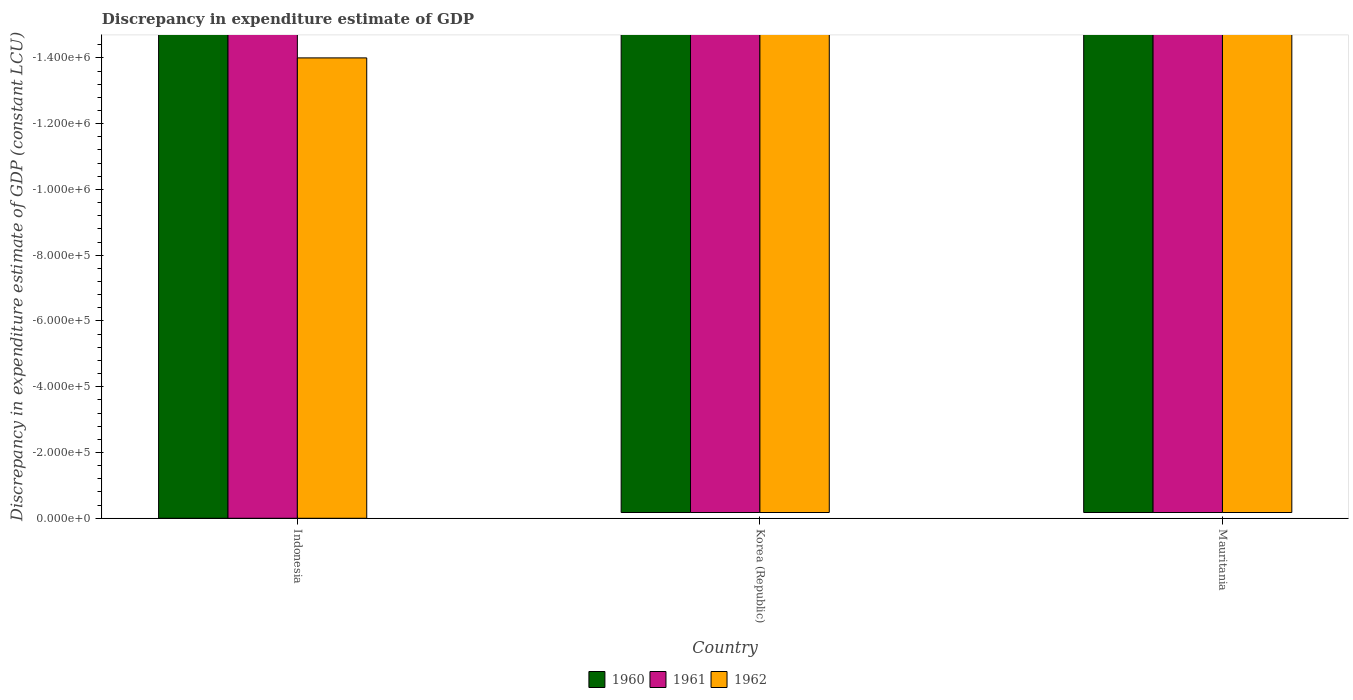Are the number of bars per tick equal to the number of legend labels?
Make the answer very short. No. Are the number of bars on each tick of the X-axis equal?
Provide a short and direct response. Yes. How many bars are there on the 2nd tick from the right?
Your answer should be compact. 0. What is the label of the 2nd group of bars from the left?
Your answer should be compact. Korea (Republic). What is the discrepancy in expenditure estimate of GDP in 1961 in Korea (Republic)?
Offer a terse response. 0. What is the total discrepancy in expenditure estimate of GDP in 1960 in the graph?
Your answer should be very brief. 0. What is the difference between the discrepancy in expenditure estimate of GDP in 1960 in Korea (Republic) and the discrepancy in expenditure estimate of GDP in 1961 in Mauritania?
Your answer should be very brief. 0. In how many countries, is the discrepancy in expenditure estimate of GDP in 1961 greater than -560000 LCU?
Offer a very short reply. 0. In how many countries, is the discrepancy in expenditure estimate of GDP in 1961 greater than the average discrepancy in expenditure estimate of GDP in 1961 taken over all countries?
Make the answer very short. 0. How many bars are there?
Your answer should be very brief. 0. How many countries are there in the graph?
Ensure brevity in your answer.  3. Are the values on the major ticks of Y-axis written in scientific E-notation?
Keep it short and to the point. Yes. Does the graph contain any zero values?
Offer a very short reply. Yes. Does the graph contain grids?
Ensure brevity in your answer.  No. Where does the legend appear in the graph?
Offer a very short reply. Bottom center. How many legend labels are there?
Your answer should be very brief. 3. How are the legend labels stacked?
Provide a succinct answer. Horizontal. What is the title of the graph?
Your response must be concise. Discrepancy in expenditure estimate of GDP. Does "2004" appear as one of the legend labels in the graph?
Make the answer very short. No. What is the label or title of the X-axis?
Ensure brevity in your answer.  Country. What is the label or title of the Y-axis?
Provide a succinct answer. Discrepancy in expenditure estimate of GDP (constant LCU). What is the Discrepancy in expenditure estimate of GDP (constant LCU) of 1961 in Mauritania?
Make the answer very short. 0. What is the total Discrepancy in expenditure estimate of GDP (constant LCU) in 1960 in the graph?
Your response must be concise. 0. What is the total Discrepancy in expenditure estimate of GDP (constant LCU) of 1961 in the graph?
Your response must be concise. 0. What is the total Discrepancy in expenditure estimate of GDP (constant LCU) of 1962 in the graph?
Keep it short and to the point. 0. What is the average Discrepancy in expenditure estimate of GDP (constant LCU) in 1960 per country?
Give a very brief answer. 0. What is the average Discrepancy in expenditure estimate of GDP (constant LCU) of 1962 per country?
Make the answer very short. 0. 